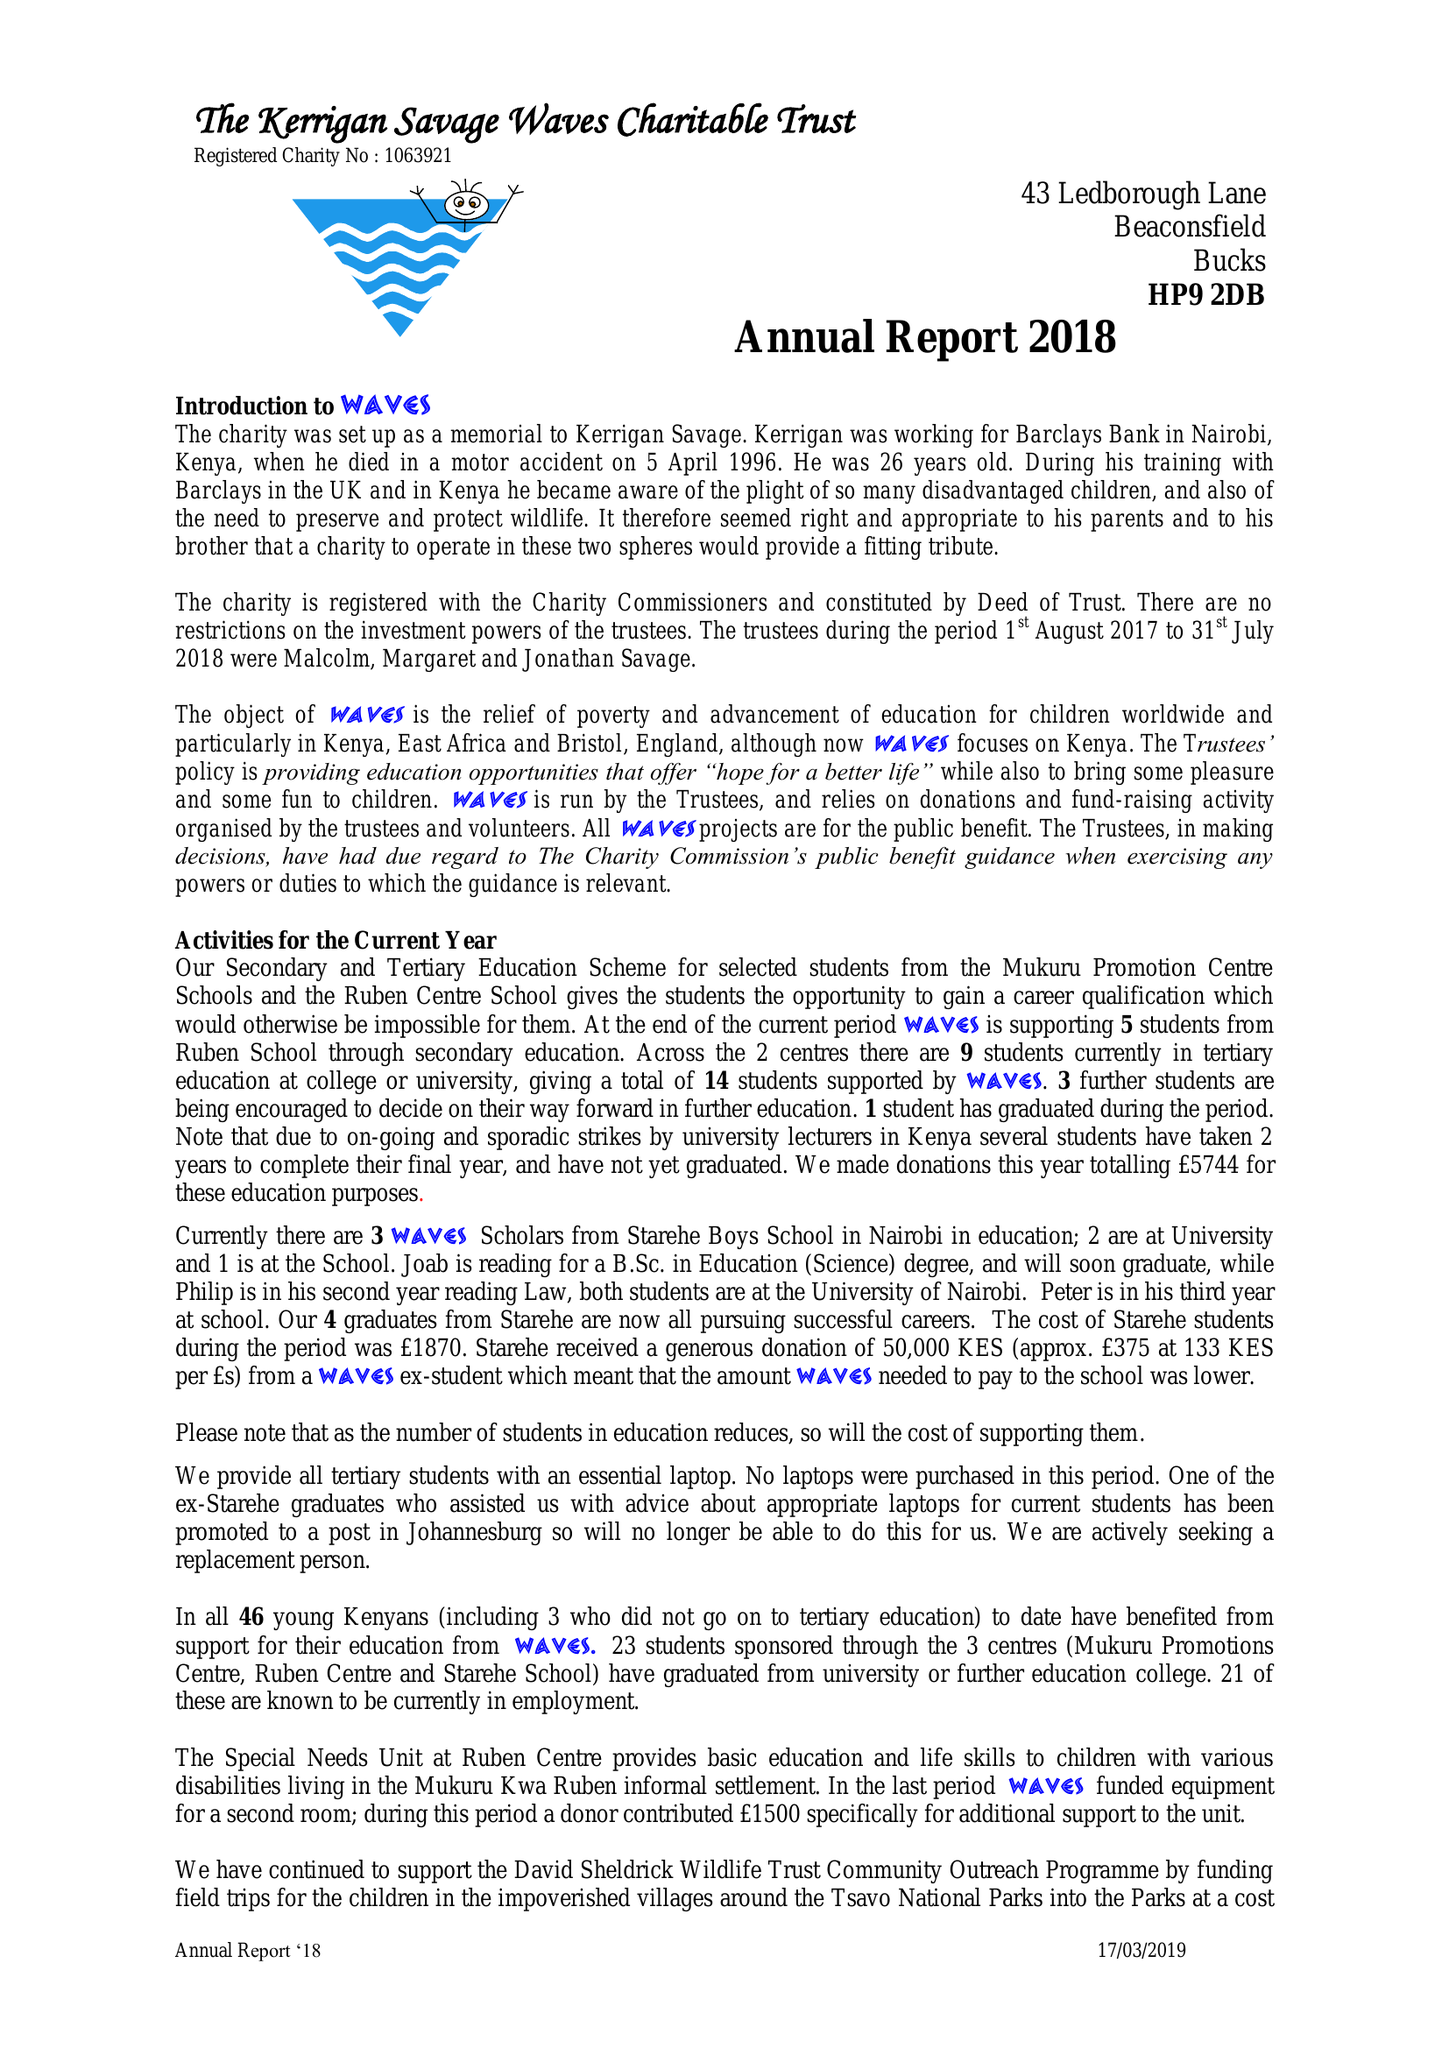What is the value for the address__street_line?
Answer the question using a single word or phrase. 43 LEDBOROUGH LANE 